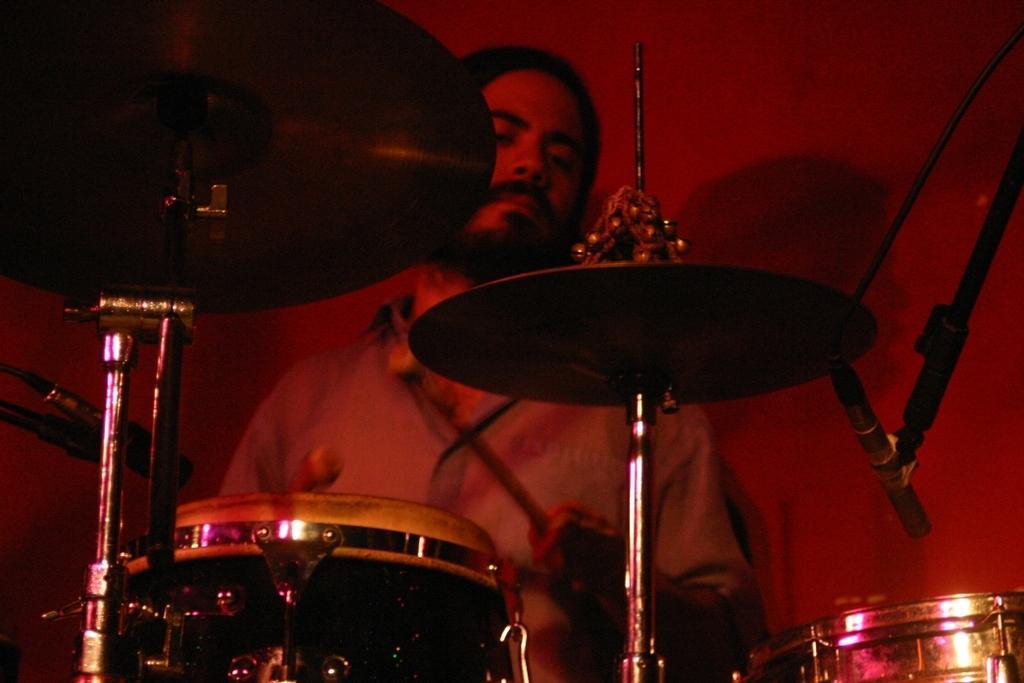Describe this image in one or two sentences. In this image I can see a man and I can see he is holding two drumsticks. In the front of him I can see a drum set and few mics. 